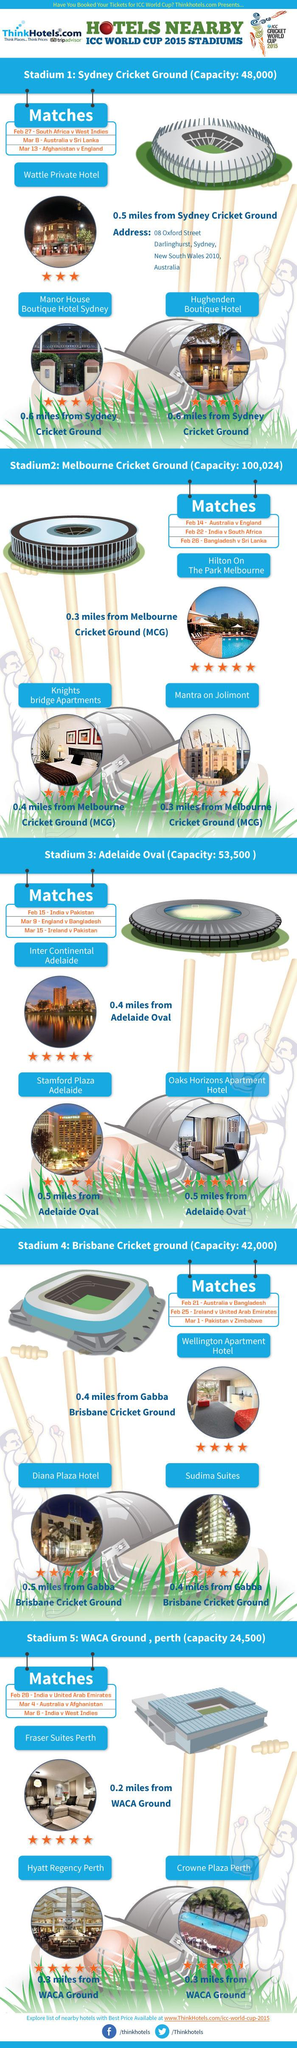Highlight a few significant elements in this photo. There are four hotels that have a five-star rating. As of my knowledge cutoff date, there were 1 hotel with a 3-star rating. There are six hotels that have a 4-star rating. Mantra on Jolimont is the closest hotel to Melbourne Cricket Ground, and Knights Bridge Apartments and which hotels are located near Melbourne Cricket Ground? The Hughenden boutique hotel and the Wattle private hotel are both located near the Sydney Cricket Ground. The Wattle private hotel is closer to the Sydney Cricket Ground. 